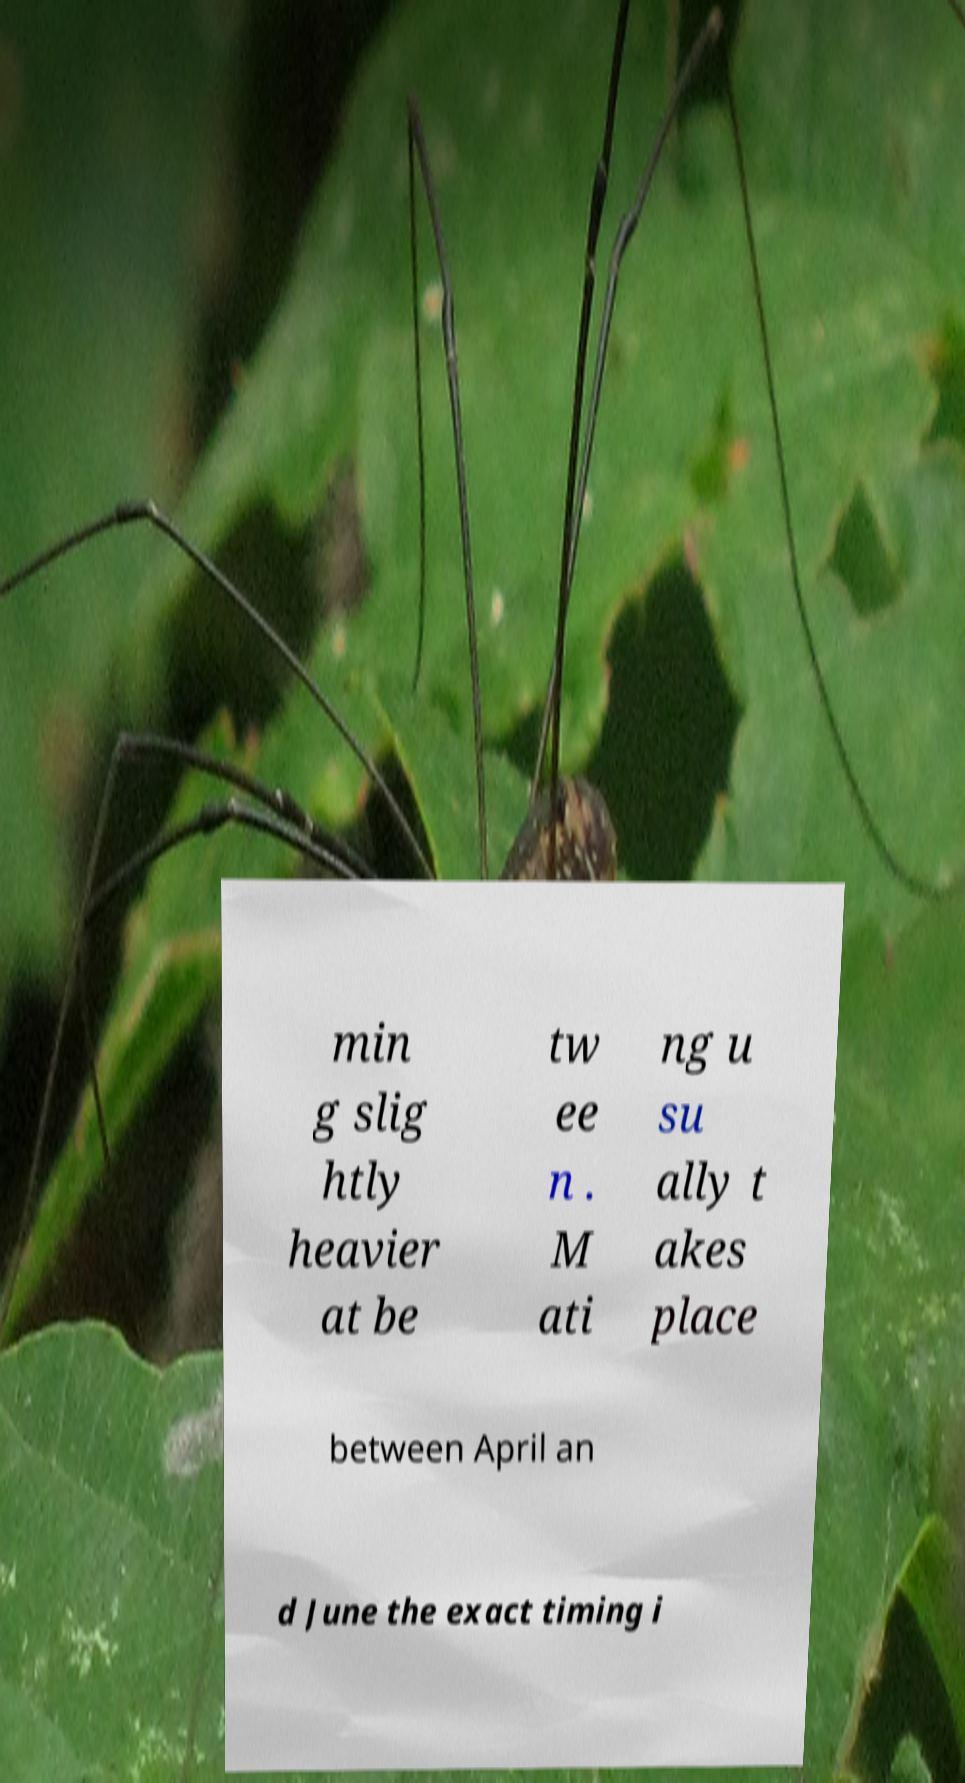Could you assist in decoding the text presented in this image and type it out clearly? min g slig htly heavier at be tw ee n . M ati ng u su ally t akes place between April an d June the exact timing i 